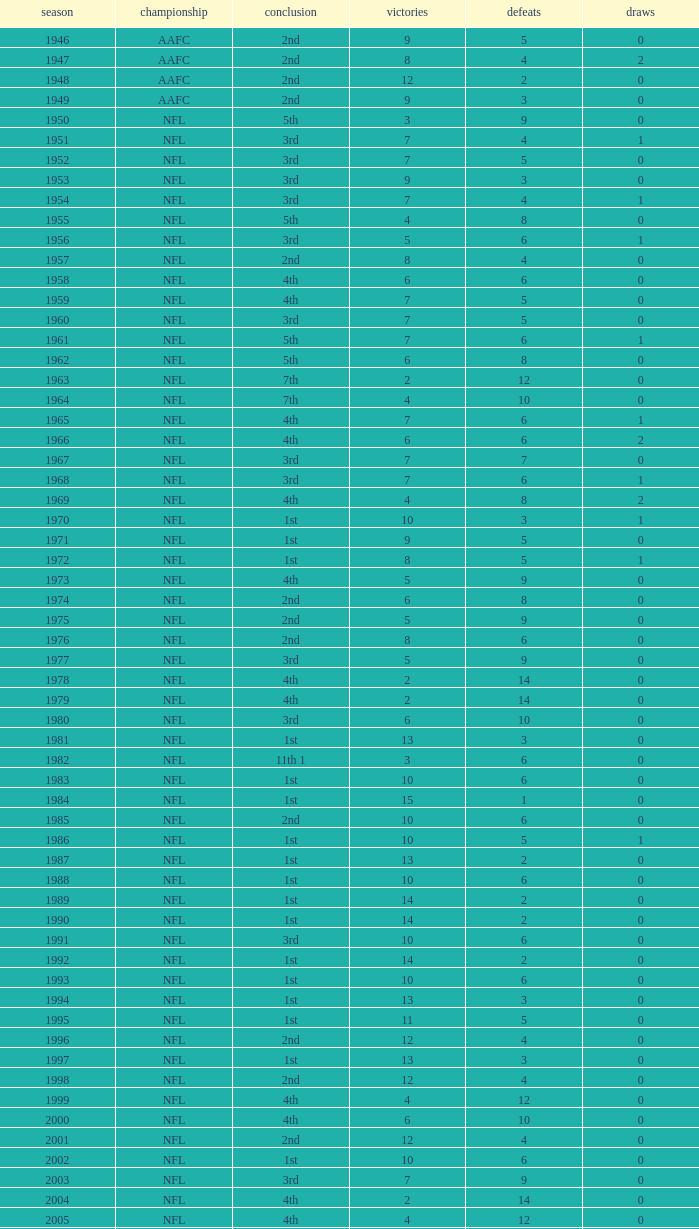What league had a finish of 2nd and 3 losses? AAFC. 